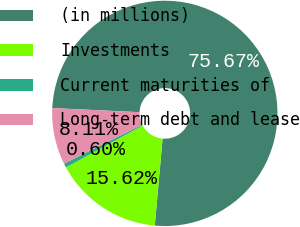Convert chart. <chart><loc_0><loc_0><loc_500><loc_500><pie_chart><fcel>(in millions)<fcel>Investments<fcel>Current maturities of<fcel>Long-term debt and lease<nl><fcel>75.67%<fcel>15.62%<fcel>0.6%<fcel>8.11%<nl></chart> 